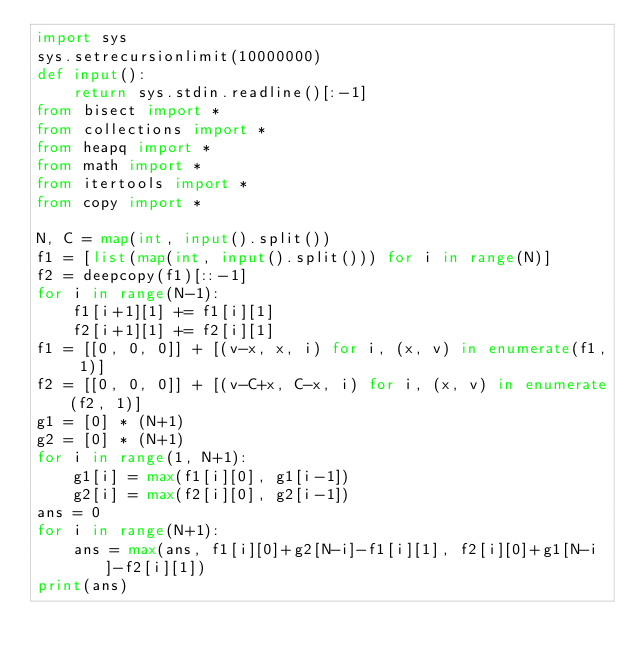<code> <loc_0><loc_0><loc_500><loc_500><_Python_>import sys
sys.setrecursionlimit(10000000)
def input():
    return sys.stdin.readline()[:-1]
from bisect import *
from collections import *
from heapq import *
from math import *
from itertools import *
from copy import *

N, C = map(int, input().split())
f1 = [list(map(int, input().split())) for i in range(N)]
f2 = deepcopy(f1)[::-1]
for i in range(N-1):
    f1[i+1][1] += f1[i][1]
    f2[i+1][1] += f2[i][1]
f1 = [[0, 0, 0]] + [(v-x, x, i) for i, (x, v) in enumerate(f1, 1)]
f2 = [[0, 0, 0]] + [(v-C+x, C-x, i) for i, (x, v) in enumerate(f2, 1)]
g1 = [0] * (N+1)
g2 = [0] * (N+1)
for i in range(1, N+1):
    g1[i] = max(f1[i][0], g1[i-1])
    g2[i] = max(f2[i][0], g2[i-1])
ans = 0
for i in range(N+1):
    ans = max(ans, f1[i][0]+g2[N-i]-f1[i][1], f2[i][0]+g1[N-i]-f2[i][1])
print(ans)
</code> 